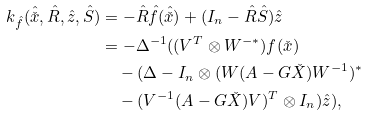Convert formula to latex. <formula><loc_0><loc_0><loc_500><loc_500>k _ { \hat { f } } ( \hat { \check { x } } , \hat { R } , \hat { z } , \hat { S } ) & = - \hat { R } \hat { f } ( \hat { \check { x } } ) + ( I _ { n } - \hat { R } \hat { S } ) \hat { z } \\ & = - \Delta ^ { - 1 } ( ( V ^ { T } \otimes W ^ { - * } ) f ( \check { x } ) \\ & \quad - ( \Delta - I _ { n } \otimes ( W ( { A } - G \check { X } ) W ^ { - 1 } ) ^ { * } \\ & \quad - ( V ^ { - 1 } ( A - G \check { X } ) V ) ^ { T } \otimes I _ { n } ) \hat { z } ) ,</formula> 